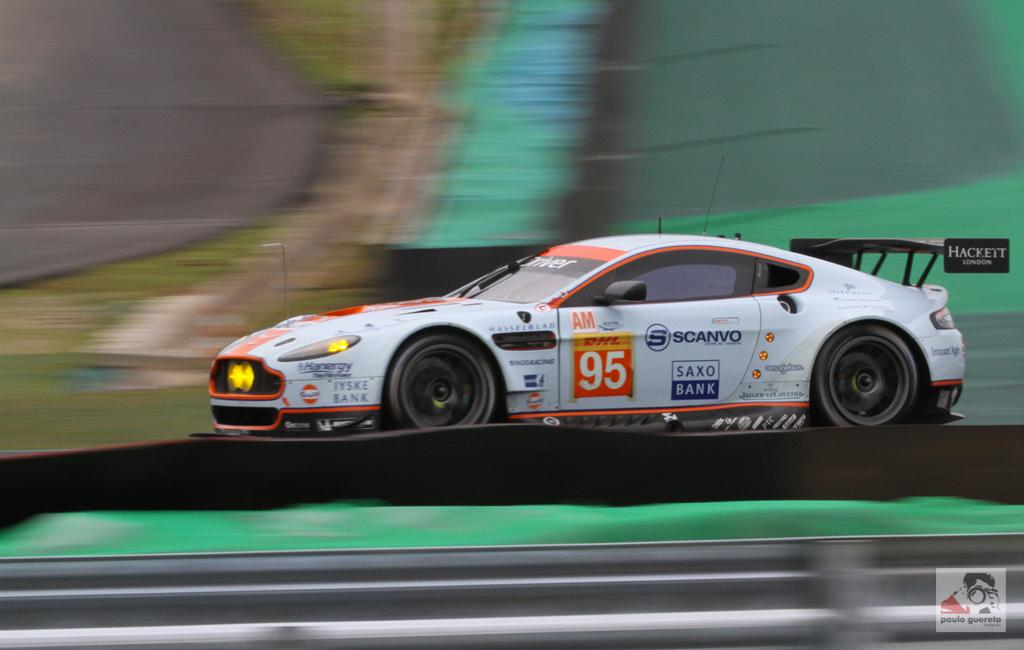What is the main subject of the image? There is a car in the image. Where is the car located? The car is on the road. Can you tell me how many sheep are in the flock that is following the car in the image? There is no flock of sheep or any other animals following the car in the image. 